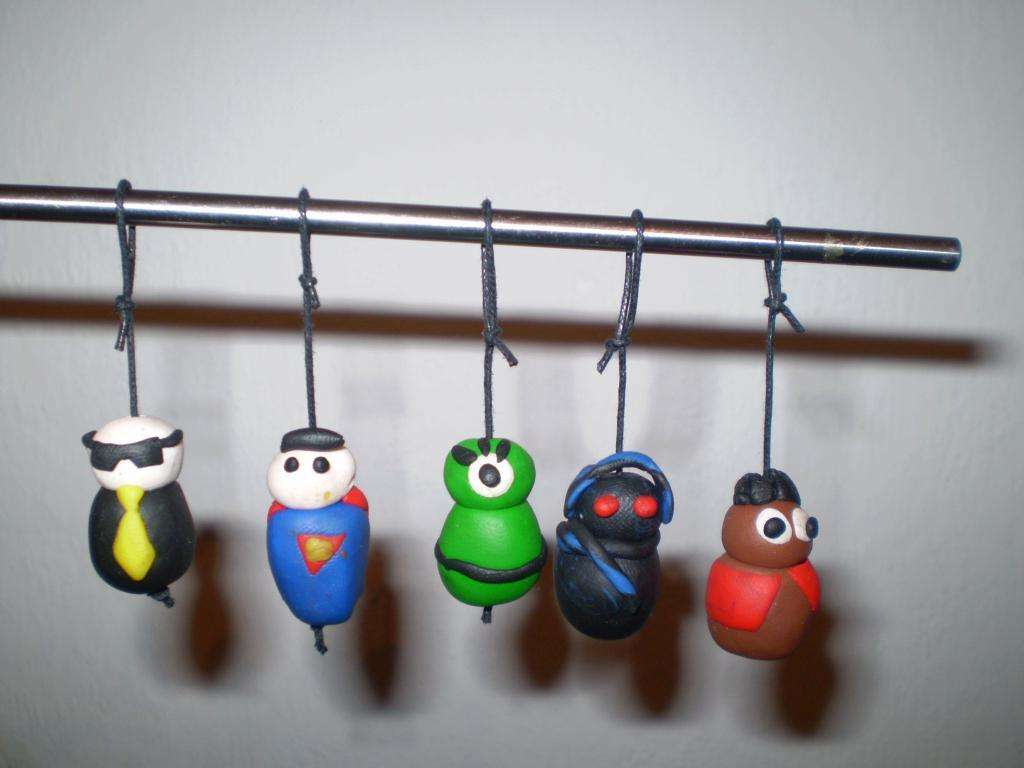What type of puppets are featured in the image? There are puppets made with clay in the image. How are the puppets displayed in the image? The puppets are tied and hanged on a road. What can be observed about the appearance of the puppets? The puppets are in different colors. What is visible in the background of the image? There is a wall in the background of the image. What activity is the farmer performing with the puppets in the image? There is no farmer present in the image, and the puppets are simply displayed on a road. 